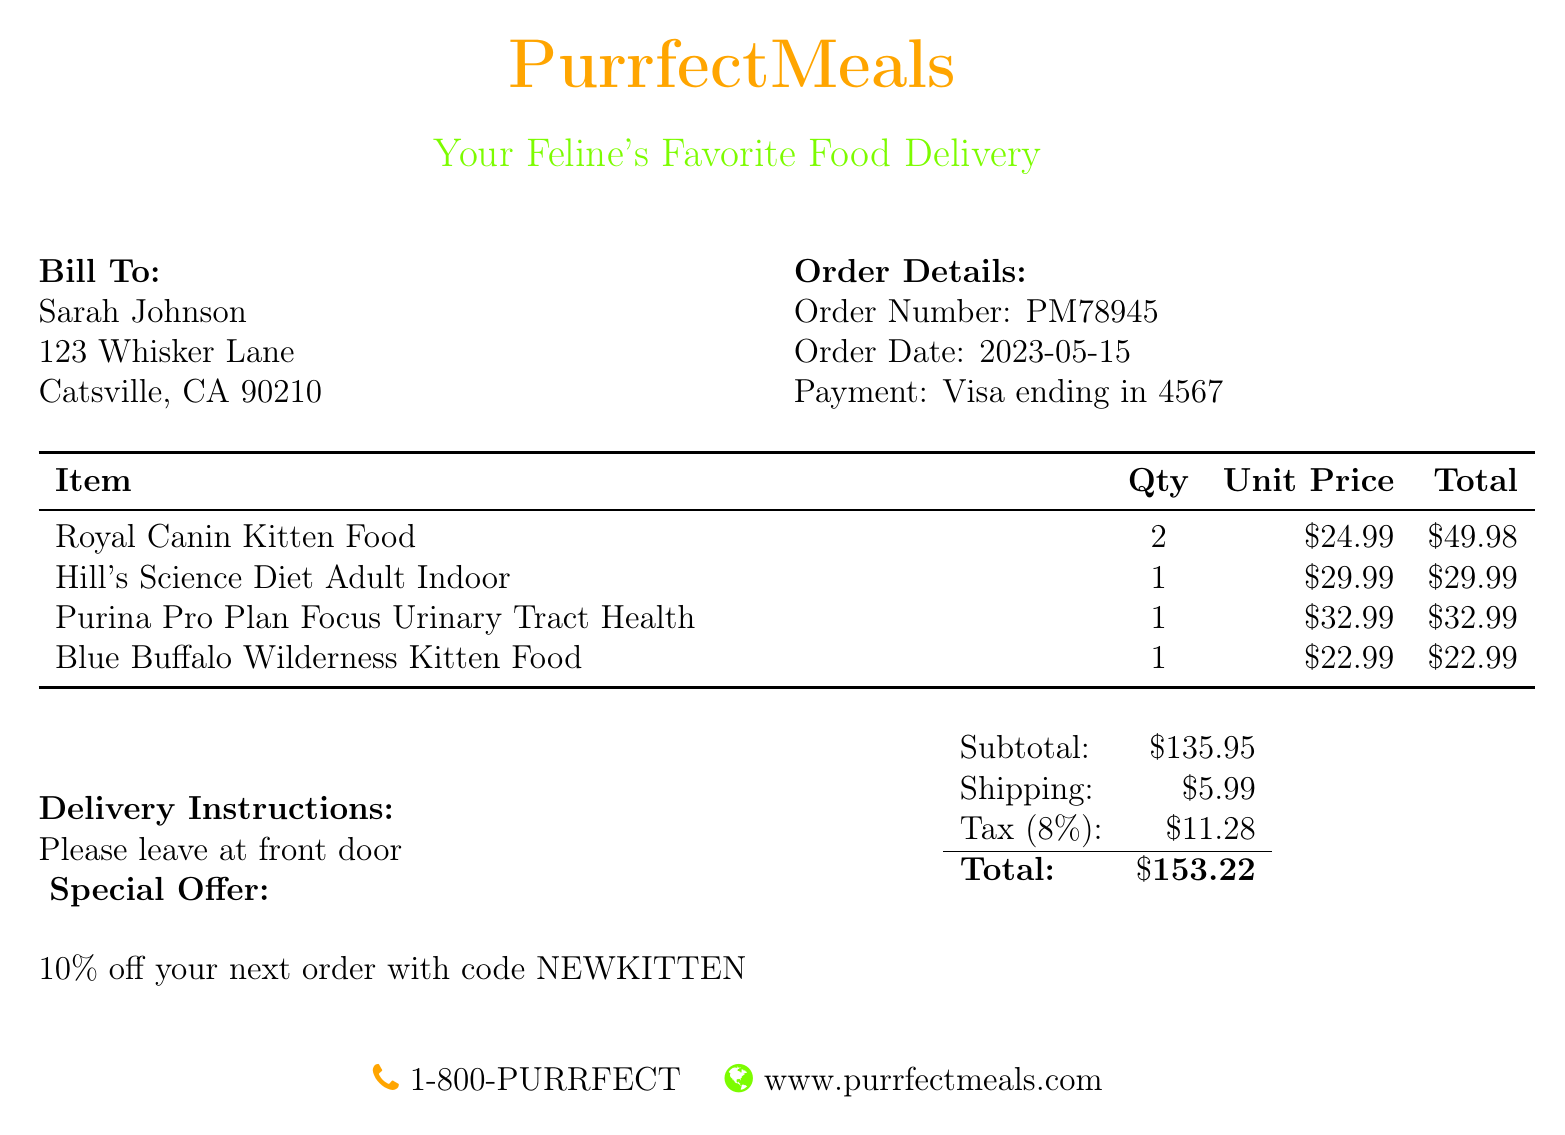What is the order number? The order number is specified in the document, found under the order details.
Answer: PM78945 What is the subtotal before tax? The subtotal is listed in the document under the financial summary section.
Answer: $135.95 Who is the bill addressed to? The recipient's name is found at the beginning of the document in the "Bill To" section.
Answer: Sarah Johnson What is the delivery charge? The delivery charge can be found in the financial breakdown of the document.
Answer: $5.99 How much is the tax? The tax amount is indicated in the financial summary section of the document.
Answer: $11.28 What type of food is listed for adult cats? The type of food specifically mentioned for adult cats can be found in the itemized list.
Answer: Hill's Science Diet Adult Indoor What is the total amount due? The total amount is detailed in the financial summary at the end of the document.
Answer: $153.22 What percentage discount does the special offer provide? The special offer discount percentage is stated in the delivery instructions section.
Answer: 10% How many Royal Canin Kitten Foods were ordered? The quantity of each item ordered is listed in the itemized table.
Answer: 2 